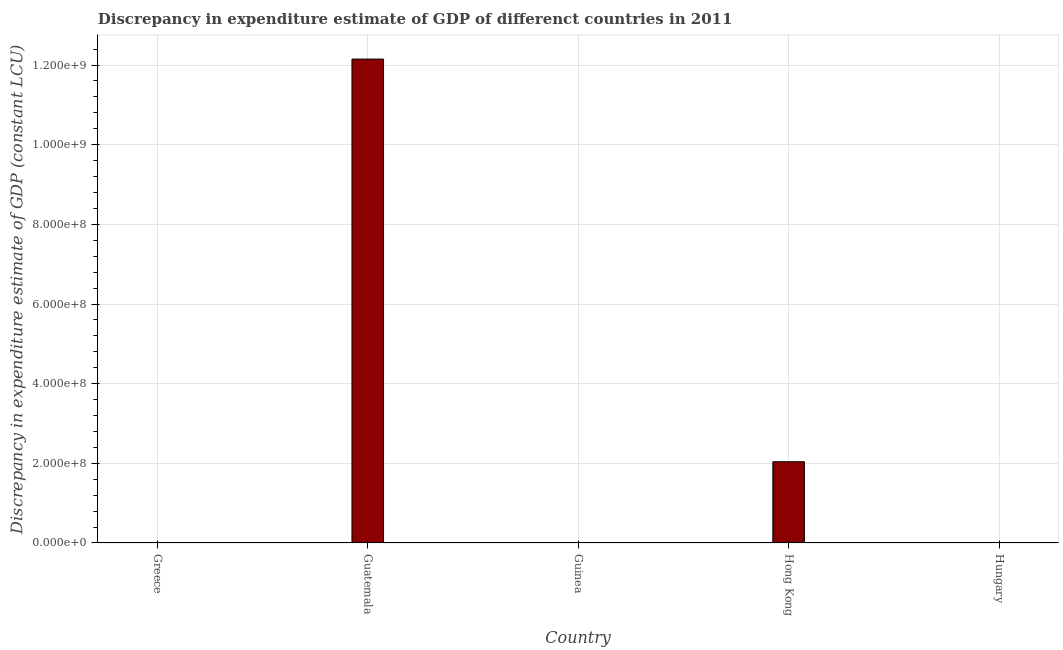Does the graph contain any zero values?
Keep it short and to the point. Yes. What is the title of the graph?
Provide a succinct answer. Discrepancy in expenditure estimate of GDP of differenct countries in 2011. What is the label or title of the Y-axis?
Ensure brevity in your answer.  Discrepancy in expenditure estimate of GDP (constant LCU). Across all countries, what is the maximum discrepancy in expenditure estimate of gdp?
Make the answer very short. 1.22e+09. In which country was the discrepancy in expenditure estimate of gdp maximum?
Your response must be concise. Guatemala. What is the sum of the discrepancy in expenditure estimate of gdp?
Ensure brevity in your answer.  1.42e+09. What is the difference between the discrepancy in expenditure estimate of gdp in Greece and Hong Kong?
Provide a short and direct response. -2.04e+08. What is the average discrepancy in expenditure estimate of gdp per country?
Make the answer very short. 2.84e+08. What is the median discrepancy in expenditure estimate of gdp?
Your response must be concise. 800. In how many countries, is the discrepancy in expenditure estimate of gdp greater than 1080000000 LCU?
Offer a terse response. 1. What is the ratio of the discrepancy in expenditure estimate of gdp in Greece to that in Hong Kong?
Give a very brief answer. 0. Is the discrepancy in expenditure estimate of gdp in Guinea less than that in Hong Kong?
Your response must be concise. Yes. Is the difference between the discrepancy in expenditure estimate of gdp in Greece and Guinea greater than the difference between any two countries?
Your answer should be very brief. No. What is the difference between the highest and the second highest discrepancy in expenditure estimate of gdp?
Your answer should be very brief. 1.01e+09. Is the sum of the discrepancy in expenditure estimate of gdp in Greece and Guinea greater than the maximum discrepancy in expenditure estimate of gdp across all countries?
Your answer should be very brief. No. What is the difference between the highest and the lowest discrepancy in expenditure estimate of gdp?
Your answer should be very brief. 1.22e+09. In how many countries, is the discrepancy in expenditure estimate of gdp greater than the average discrepancy in expenditure estimate of gdp taken over all countries?
Keep it short and to the point. 1. How many bars are there?
Offer a terse response. 4. How many countries are there in the graph?
Offer a terse response. 5. What is the Discrepancy in expenditure estimate of GDP (constant LCU) in Greece?
Make the answer very short. 800. What is the Discrepancy in expenditure estimate of GDP (constant LCU) in Guatemala?
Ensure brevity in your answer.  1.22e+09. What is the Discrepancy in expenditure estimate of GDP (constant LCU) of Hong Kong?
Provide a succinct answer. 2.04e+08. What is the difference between the Discrepancy in expenditure estimate of GDP (constant LCU) in Greece and Guatemala?
Your answer should be compact. -1.21e+09. What is the difference between the Discrepancy in expenditure estimate of GDP (constant LCU) in Greece and Guinea?
Ensure brevity in your answer.  700. What is the difference between the Discrepancy in expenditure estimate of GDP (constant LCU) in Greece and Hong Kong?
Give a very brief answer. -2.04e+08. What is the difference between the Discrepancy in expenditure estimate of GDP (constant LCU) in Guatemala and Guinea?
Your answer should be very brief. 1.21e+09. What is the difference between the Discrepancy in expenditure estimate of GDP (constant LCU) in Guatemala and Hong Kong?
Your answer should be compact. 1.01e+09. What is the difference between the Discrepancy in expenditure estimate of GDP (constant LCU) in Guinea and Hong Kong?
Provide a short and direct response. -2.04e+08. What is the ratio of the Discrepancy in expenditure estimate of GDP (constant LCU) in Greece to that in Guinea?
Provide a succinct answer. 8. What is the ratio of the Discrepancy in expenditure estimate of GDP (constant LCU) in Greece to that in Hong Kong?
Your answer should be very brief. 0. What is the ratio of the Discrepancy in expenditure estimate of GDP (constant LCU) in Guatemala to that in Guinea?
Provide a short and direct response. 1.22e+07. What is the ratio of the Discrepancy in expenditure estimate of GDP (constant LCU) in Guatemala to that in Hong Kong?
Your answer should be compact. 5.96. 